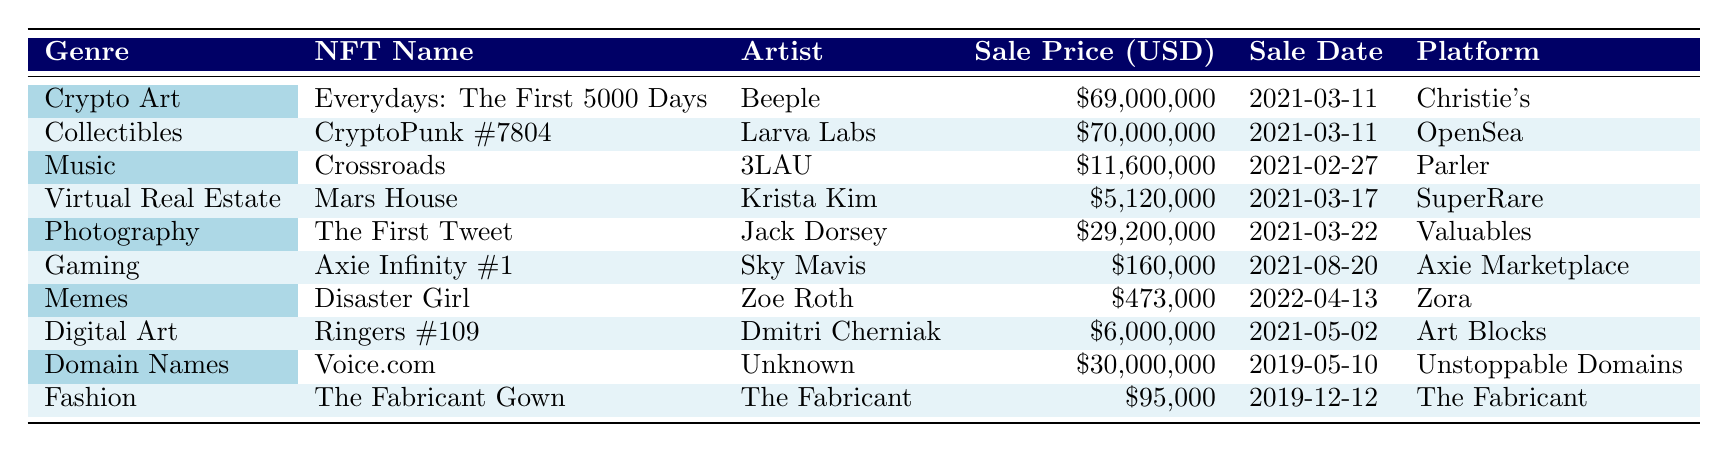What is the highest sale price among all the NFTs listed? The sale prices for each NFT are: $69,000,000 (Crypto Art), $70,000,000 (Collectibles), $11,600,000 (Music), $5,120,000 (Virtual Real Estate), $29,200,000 (Photography), $160,000 (Gaming), $473,000 (Memes), $6,000,000 (Digital Art), $30,000,000 (Domain Names), and $95,000 (Fashion). The highest price is $70,000,000 for CryptoPunk #7804.
Answer: $70,000,000 Which NFT was sold on the earliest date? The sale dates for the NFTs are: 2021-03-11 (Crypto Art), 2021-03-11 (Collectibles), 2021-02-27 (Music), 2021-03-17 (Virtual Real Estate), 2021-03-22 (Photography), 2021-08-20 (Gaming), 2022-04-13 (Memes), 2021-05-02 (Digital Art), 2019-05-10 (Domain Names), and 2019-12-12 (Fashion). The earliest sale date is 2019-05-10 for Voice.com.
Answer: Voice.com What is the total sale price of all NFTs in the Music genre? The only NFT in the Music genre is Crossroads, sold for $11,600,000. Since there is only one NFT, the total sale price is the same as the sale price of that NFT.
Answer: $11,600,000 How many NFTs were sold for more than $20,000,000? Examining the sale prices: $69,000,000 (Crypto Art), $70,000,000 (Collectibles), $29,200,000 (Photography), and $30,000,000 (Domain Names) are all greater than $20,000,000. Counting them gives us 4 NFTs.
Answer: 4 What genre had the lowest sale price among the NFTs listed? By comparing the sale prices, $69,000,000 (Crypto Art), $70,000,000 (Collectibles), $11,600,000 (Music), $5,120,000 (Virtual Real Estate), $29,200,000 (Photography), $160,000 (Gaming), $473,000 (Memes), $6,000,000 (Digital Art), $30,000,000 (Domain Names), and $95,000 (Fashion), we can see that Gaming at $160,000 has the lowest sale price.
Answer: Gaming What percentage of the total sales come from the top two highest-selling NFTs? The top two NFT sales are $70,000,000 and $69,000,000, totaling $139,000,000. The sum of all NFT sales (from the data provided) totals to $259,360,000. Therefore, the percentage is (139,000,000 / 259,360,000) * 100 ≈ 53.6%.
Answer: 53.6% Is there any NFT from the Fashion genre that sold for less than $100,000? The only NFT listed in the Fashion genre is The Fabricant Gown, sold for $95,000. Since this price is less than $100,000, the statement is true.
Answer: Yes What is the average sale price of NFTs in the Digital Art and Virtual Real Estate genres combined? The sale price for Digital Art (Ringers #109) is $6,000,000 and for Virtual Real Estate (Mars House) is $5,120,000. Adding them gives $11,120,000. There are 2 NFTs in these genres, so the average is $11,120,000 / 2 = $5,560,000.
Answer: $5,560,000 